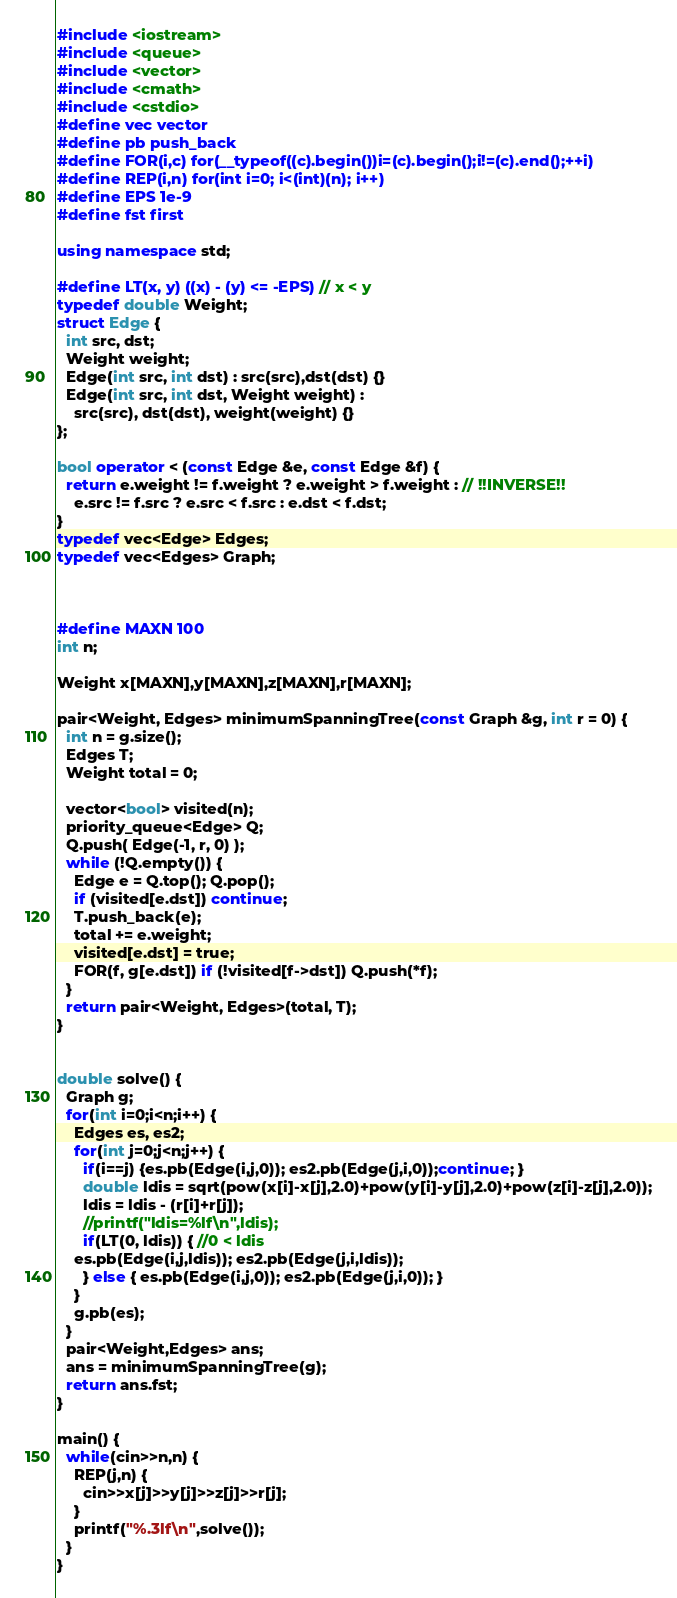Convert code to text. <code><loc_0><loc_0><loc_500><loc_500><_C++_>#include <iostream>
#include <queue>
#include <vector>
#include <cmath>
#include <cstdio>
#define vec vector
#define pb push_back
#define FOR(i,c) for(__typeof((c).begin())i=(c).begin();i!=(c).end();++i)
#define REP(i,n) for(int i=0; i<(int)(n); i++)
#define EPS 1e-9
#define fst first

using namespace std;

#define LT(x, y) ((x) - (y) <= -EPS) // x < y
typedef double Weight;
struct Edge {
  int src, dst;
  Weight weight;
  Edge(int src, int dst) : src(src),dst(dst) {}
  Edge(int src, int dst, Weight weight) :
    src(src), dst(dst), weight(weight) {}
};

bool operator < (const Edge &e, const Edge &f) {
  return e.weight != f.weight ? e.weight > f.weight : // !!INVERSE!!
    e.src != f.src ? e.src < f.src : e.dst < f.dst;
}
typedef vec<Edge> Edges;
typedef vec<Edges> Graph;



#define MAXN 100
int n;

Weight x[MAXN],y[MAXN],z[MAXN],r[MAXN];

pair<Weight, Edges> minimumSpanningTree(const Graph &g, int r = 0) {
  int n = g.size();
  Edges T;
  Weight total = 0;

  vector<bool> visited(n);
  priority_queue<Edge> Q;
  Q.push( Edge(-1, r, 0) );
  while (!Q.empty()) {
    Edge e = Q.top(); Q.pop();
    if (visited[e.dst]) continue;
    T.push_back(e);
    total += e.weight;
    visited[e.dst] = true;
    FOR(f, g[e.dst]) if (!visited[f->dst]) Q.push(*f);
  }
  return pair<Weight, Edges>(total, T);
}


double solve() {
  Graph g;
  for(int i=0;i<n;i++) {
    Edges es, es2;
    for(int j=0;j<n;j++) {
      if(i==j) {es.pb(Edge(i,j,0)); es2.pb(Edge(j,i,0));continue; }
      double ldis = sqrt(pow(x[i]-x[j],2.0)+pow(y[i]-y[j],2.0)+pow(z[i]-z[j],2.0));
      ldis = ldis - (r[i]+r[j]);
      //printf("ldis=%lf\n",ldis);
      if(LT(0, ldis)) { //0 < ldis
	es.pb(Edge(i,j,ldis)); es2.pb(Edge(j,i,ldis));
      } else { es.pb(Edge(i,j,0)); es2.pb(Edge(j,i,0)); }
    }
    g.pb(es);
  }
  pair<Weight,Edges> ans;
  ans = minimumSpanningTree(g);
  return ans.fst;
}

main() {
  while(cin>>n,n) {
    REP(j,n) {
      cin>>x[j]>>y[j]>>z[j]>>r[j];
    }
    printf("%.3lf\n",solve());
  }
}</code> 